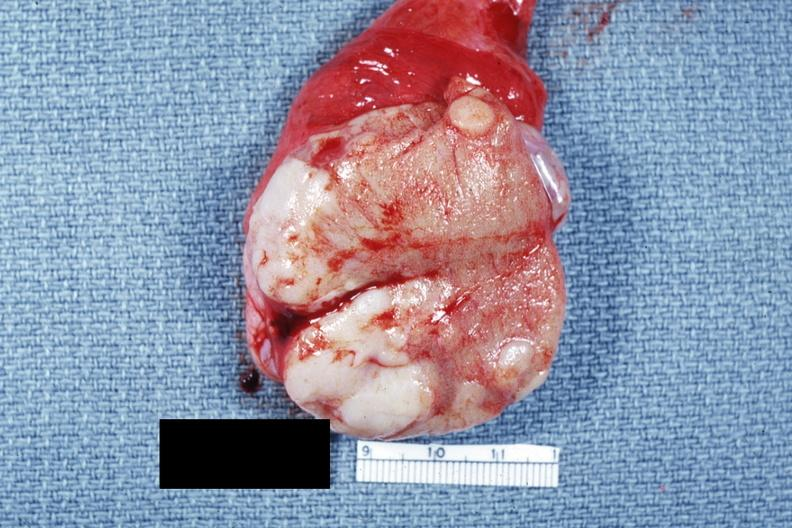what is present?
Answer the question using a single word or phrase. Testicle 